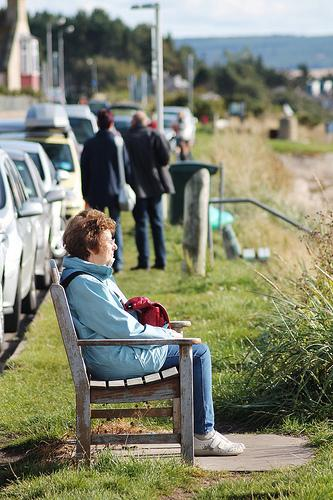Mention three details about the woman and her belongings in the image. The woman has brown hair, wears glasses and a blue jacket, and she is holding a red purse in her lap. Describe the attire of the person present in the image. The woman is wearing a light blue jacket, blue jeans, white shoes with velcro straps, and glasses on her face. Describe the background people and scenery in the image. People are standing in the background beside the parked cars, with a lamp post facing the street and a metal railing going downhill. What is the theme of the image and the overall atmosphere? The theme is a peaceful, outdoor setting with an elderly lady sitting on a bench and people, parked cars, and greenery in the background. What is the setting and environment of the image? The setting is outdoors with a wooden bench on gray cement, surrounded by greenery and parked cars on the street. What type of footwear does the woman in the image have on? The woman is wearing white sneakers with velcro straps on her feet. What are the supporting objects surrounding the main subject in the image? A light grey bench, grey concrete, and a green bush are present near the woman in the image. Describe the woman's posture and expression in the image. The woman is sitting upright on a bench, with a relaxed expression, holding a red purse and wearing glasses. Mention the type, shape, & color of the objects in the background of the image. A green, rectangular bush, gray metal railing, and a line of cars of various colors are present in the background. Provide a summary of the scene depicted in the image. An elderly woman dressed in a blue coat, blue jeans, and white sneakers, sits on an old, wooden bench holding a red purse, with a green bush and a line of parked cars in the background. 